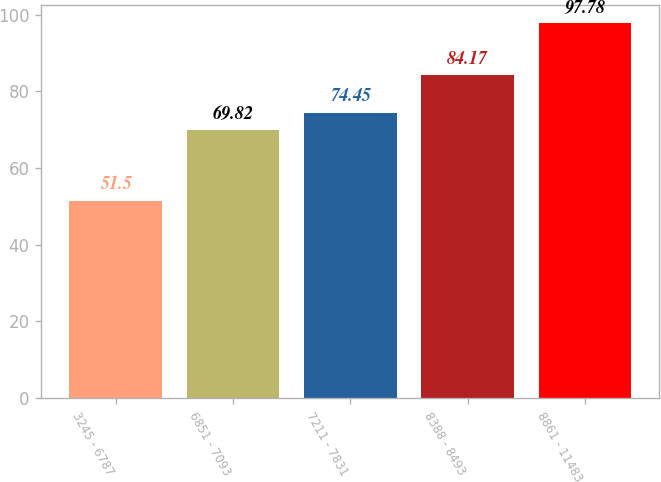<chart> <loc_0><loc_0><loc_500><loc_500><bar_chart><fcel>3245 - 6787<fcel>6851 - 7093<fcel>7211 - 7831<fcel>8388 - 8493<fcel>8861 - 11483<nl><fcel>51.5<fcel>69.82<fcel>74.45<fcel>84.17<fcel>97.78<nl></chart> 